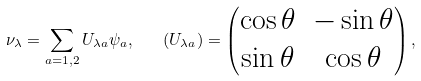Convert formula to latex. <formula><loc_0><loc_0><loc_500><loc_500>\nu _ { \lambda } = \sum _ { a = 1 , 2 } U _ { \lambda a } \psi _ { a } , \quad ( { U } _ { \lambda a } ) = \begin{pmatrix} \cos \theta & - \sin \theta \\ \sin \theta & \cos \theta \\ \end{pmatrix} ,</formula> 